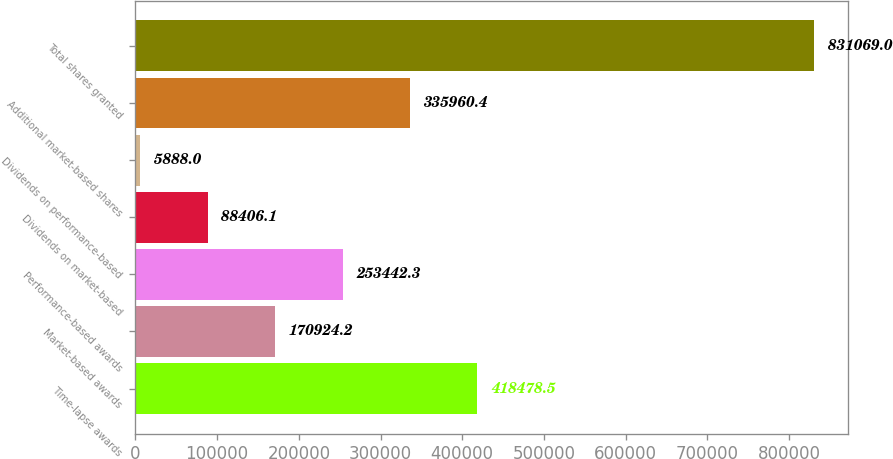Convert chart to OTSL. <chart><loc_0><loc_0><loc_500><loc_500><bar_chart><fcel>Time-lapse awards<fcel>Market-based awards<fcel>Performance-based awards<fcel>Dividends on market-based<fcel>Dividends on performance-based<fcel>Additional market-based shares<fcel>Total shares granted<nl><fcel>418478<fcel>170924<fcel>253442<fcel>88406.1<fcel>5888<fcel>335960<fcel>831069<nl></chart> 